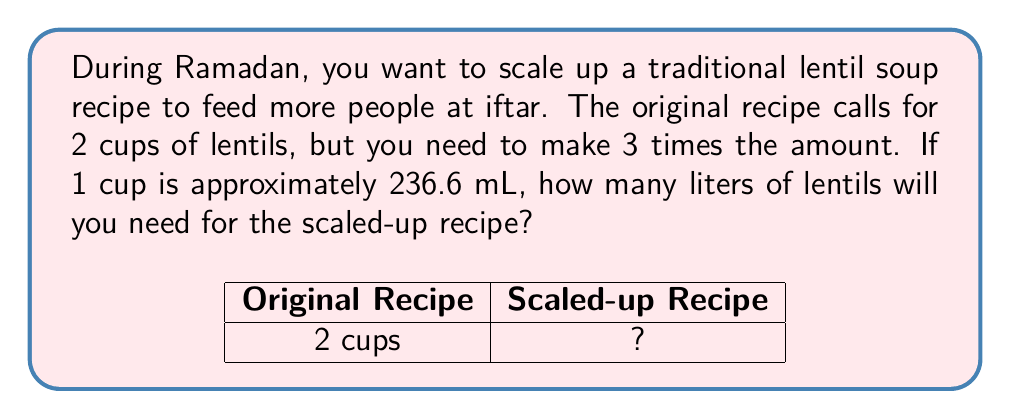Can you solve this math problem? Let's approach this step-by-step:

1) First, let's determine how many cups of lentils we need for the scaled-up recipe:
   Original recipe: 2 cups
   Scaled up 3 times: $2 \times 3 = 6$ cups

2) Now, we need to convert cups to milliliters:
   1 cup = 236.6 mL
   6 cups = $6 \times 236.6 = 1419.6$ mL

3) Finally, we need to convert milliliters to liters:
   1 L = 1000 mL
   To convert mL to L, we divide by 1000:
   $1419.6 \div 1000 = 1.4196$ L

4) Rounding to two decimal places for practicality:
   1.42 L

Therefore, you will need 1.42 liters of lentils for the scaled-up Ramadan recipe.
Answer: 1.42 L 